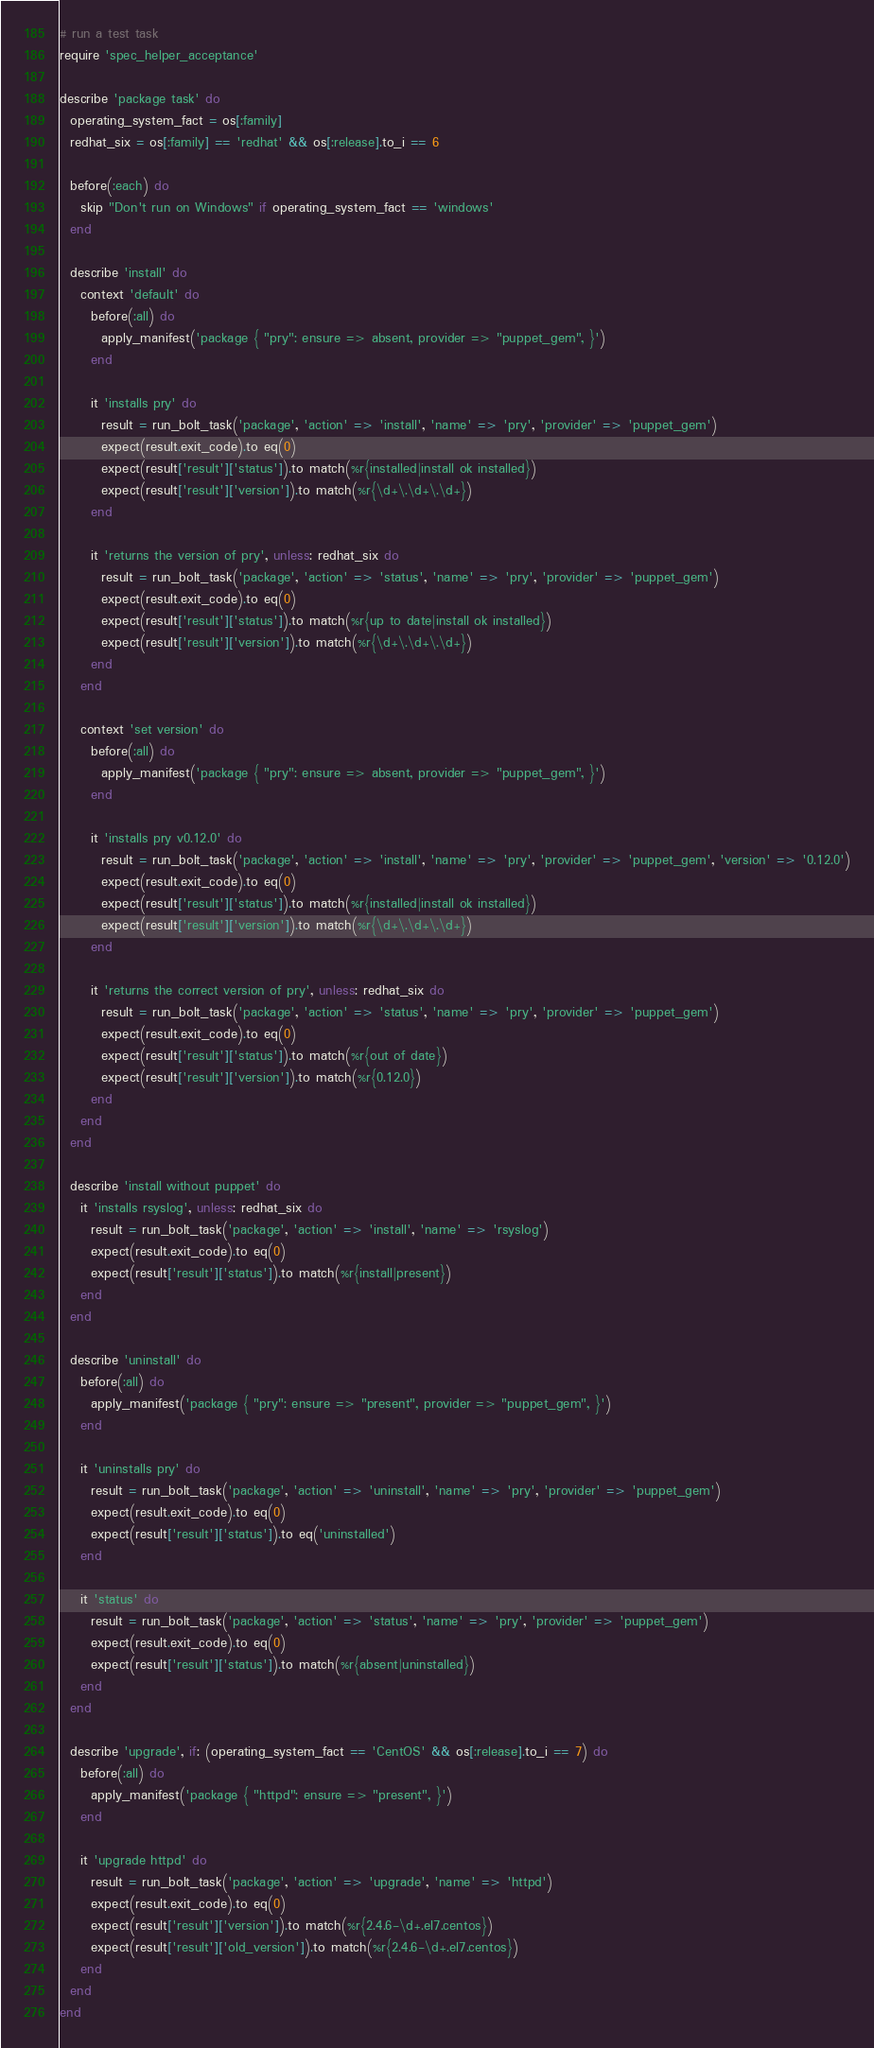<code> <loc_0><loc_0><loc_500><loc_500><_Ruby_># run a test task
require 'spec_helper_acceptance'

describe 'package task' do
  operating_system_fact = os[:family]
  redhat_six = os[:family] == 'redhat' && os[:release].to_i == 6

  before(:each) do
    skip "Don't run on Windows" if operating_system_fact == 'windows'
  end

  describe 'install' do
    context 'default' do
      before(:all) do
        apply_manifest('package { "pry": ensure => absent, provider => "puppet_gem", }')
      end

      it 'installs pry' do
        result = run_bolt_task('package', 'action' => 'install', 'name' => 'pry', 'provider' => 'puppet_gem')
        expect(result.exit_code).to eq(0)
        expect(result['result']['status']).to match(%r{installed|install ok installed})
        expect(result['result']['version']).to match(%r{\d+\.\d+\.\d+})
      end

      it 'returns the version of pry', unless: redhat_six do
        result = run_bolt_task('package', 'action' => 'status', 'name' => 'pry', 'provider' => 'puppet_gem')
        expect(result.exit_code).to eq(0)
        expect(result['result']['status']).to match(%r{up to date|install ok installed})
        expect(result['result']['version']).to match(%r{\d+\.\d+\.\d+})
      end
    end

    context 'set version' do
      before(:all) do
        apply_manifest('package { "pry": ensure => absent, provider => "puppet_gem", }')
      end

      it 'installs pry v0.12.0' do
        result = run_bolt_task('package', 'action' => 'install', 'name' => 'pry', 'provider' => 'puppet_gem', 'version' => '0.12.0')
        expect(result.exit_code).to eq(0)
        expect(result['result']['status']).to match(%r{installed|install ok installed})
        expect(result['result']['version']).to match(%r{\d+\.\d+\.\d+})
      end

      it 'returns the correct version of pry', unless: redhat_six do
        result = run_bolt_task('package', 'action' => 'status', 'name' => 'pry', 'provider' => 'puppet_gem')
        expect(result.exit_code).to eq(0)
        expect(result['result']['status']).to match(%r{out of date})
        expect(result['result']['version']).to match(%r{0.12.0})
      end
    end
  end

  describe 'install without puppet' do
    it 'installs rsyslog', unless: redhat_six do
      result = run_bolt_task('package', 'action' => 'install', 'name' => 'rsyslog')
      expect(result.exit_code).to eq(0)
      expect(result['result']['status']).to match(%r{install|present})
    end
  end

  describe 'uninstall' do
    before(:all) do
      apply_manifest('package { "pry": ensure => "present", provider => "puppet_gem", }')
    end

    it 'uninstalls pry' do
      result = run_bolt_task('package', 'action' => 'uninstall', 'name' => 'pry', 'provider' => 'puppet_gem')
      expect(result.exit_code).to eq(0)
      expect(result['result']['status']).to eq('uninstalled')
    end

    it 'status' do
      result = run_bolt_task('package', 'action' => 'status', 'name' => 'pry', 'provider' => 'puppet_gem')
      expect(result.exit_code).to eq(0)
      expect(result['result']['status']).to match(%r{absent|uninstalled})
    end
  end

  describe 'upgrade', if: (operating_system_fact == 'CentOS' && os[:release].to_i == 7) do
    before(:all) do
      apply_manifest('package { "httpd": ensure => "present", }')
    end

    it 'upgrade httpd' do
      result = run_bolt_task('package', 'action' => 'upgrade', 'name' => 'httpd')
      expect(result.exit_code).to eq(0)
      expect(result['result']['version']).to match(%r{2.4.6-\d+.el7.centos})
      expect(result['result']['old_version']).to match(%r{2.4.6-\d+.el7.centos})
    end
  end
end
</code> 